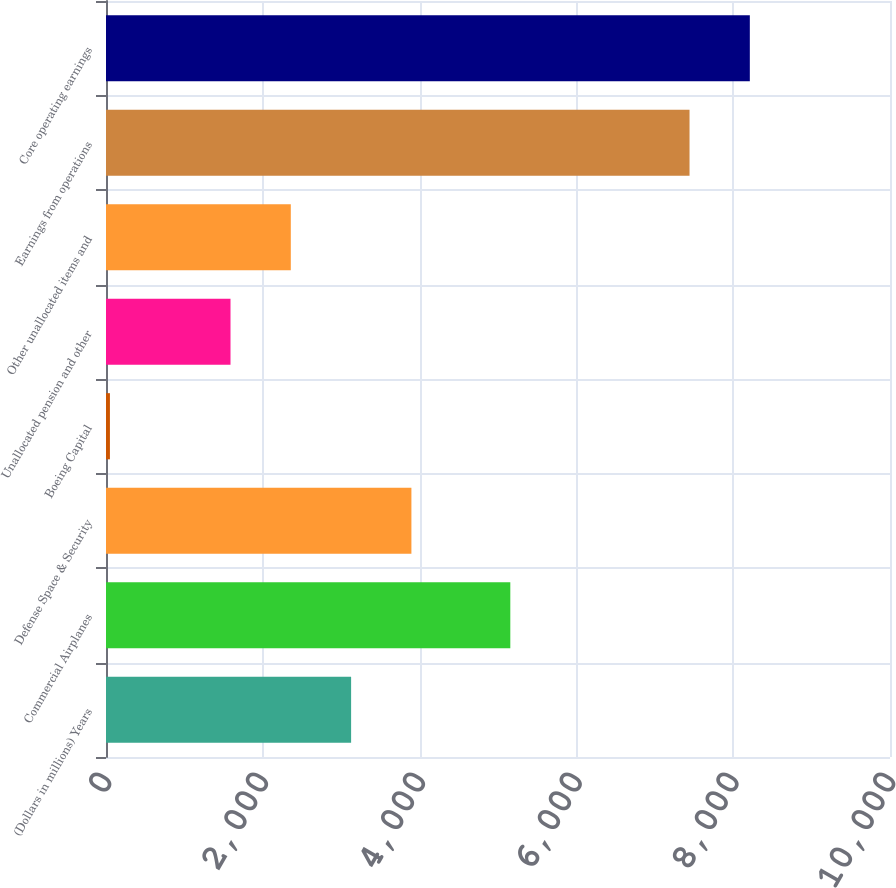Convert chart to OTSL. <chart><loc_0><loc_0><loc_500><loc_500><bar_chart><fcel>(Dollars in millions) Years<fcel>Commercial Airplanes<fcel>Defense Space & Security<fcel>Boeing Capital<fcel>Unallocated pension and other<fcel>Other unallocated items and<fcel>Earnings from operations<fcel>Core operating earnings<nl><fcel>3126.4<fcel>5157<fcel>3895.5<fcel>50<fcel>1588.2<fcel>2357.3<fcel>7443<fcel>8212.1<nl></chart> 